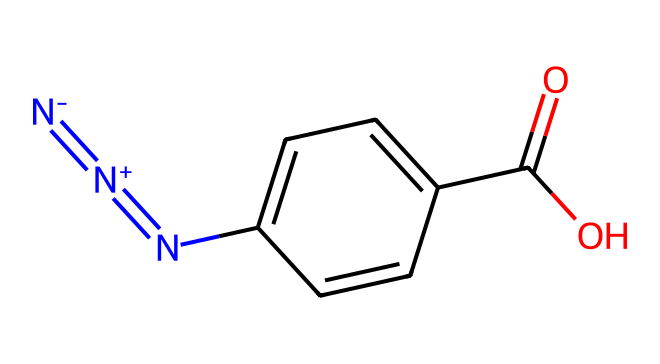what is the total number of nitrogen atoms in this azide compound? The SMILES representation indicates the presence of three nitrogen atoms: one in the azide group (N#N), one in the imine (N=C), and one as part of the entire molecule, which participates in the azide group bonding.
Answer: three how many carbon atoms are present in the chemical structure? By analyzing the SMILES representation, we can count a total of six carbon atoms; five in the aromatic ring and one in the carboxylic acid (-C(=O)O) group.
Answer: six what functional group is indicated by 'C(=O)O' in this structure? The notation 'C(=O)O' represents a carboxylic acid functional group, characterized by a carbon atom double-bonded to an oxygen atom and single-bonded to a hydroxyl group (-OH).
Answer: carboxylic acid how many double bonds are present in the entire structure? The structure shows two double bonds: one in the azide group (N#N) and another between the carbon and oxygen in the carboxylic acid group (C=O).
Answer: two what type of azide is represented in this chemical? This compound includes a functional group (i.e., an aromatic ring), which indicates that it is an aryl azide, as azides that are directly attached to an aromatic system are categorized as aryl azides.
Answer: aryl azide what property might the azide functional group contribute to high-performance athletic clothing? The azide functional group is known for its reactivity and potential for cross-linking with polymeric materials, improving durability and shape retention in fabrics, which benefits athletic wear.
Answer: durability 